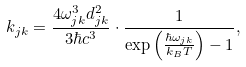<formula> <loc_0><loc_0><loc_500><loc_500>k _ { j k } = \frac { 4 \omega _ { j k } ^ { 3 } d _ { j k } ^ { 2 } } { 3 \hbar { c } ^ { 3 } } \cdot \frac { 1 } { \exp \left ( \frac { \hbar { \omega } _ { j k } } { k _ { B } T } \right ) - 1 } ,</formula> 